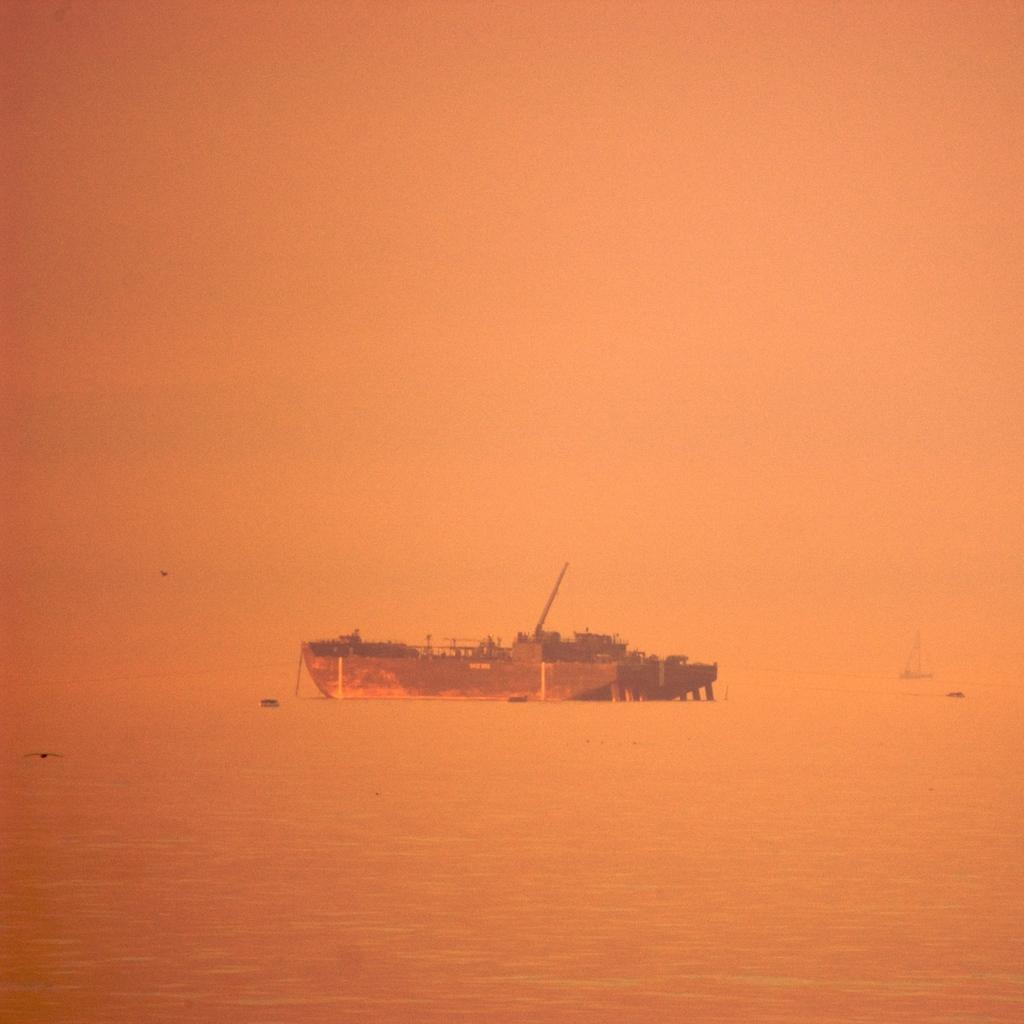What is the main subject of the image? The main subject of the image is a boat. Where is the boat located? The boat is on the sea. What else can be seen in the image besides the boat? There are birds flying in the image. What type of grass can be seen growing on the boat in the image? There is no grass growing on the boat in the image; it is on the sea. 